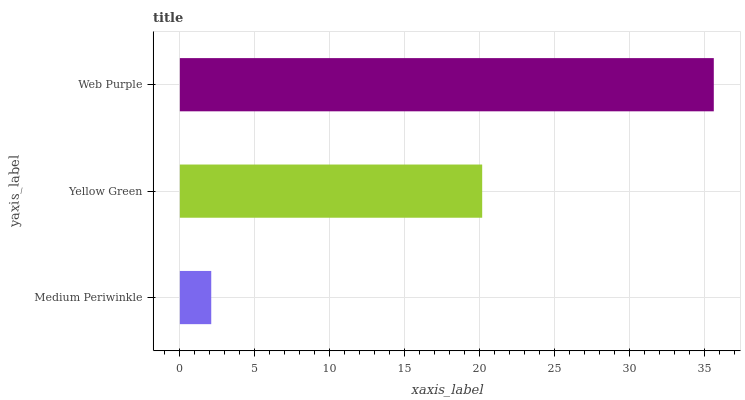Is Medium Periwinkle the minimum?
Answer yes or no. Yes. Is Web Purple the maximum?
Answer yes or no. Yes. Is Yellow Green the minimum?
Answer yes or no. No. Is Yellow Green the maximum?
Answer yes or no. No. Is Yellow Green greater than Medium Periwinkle?
Answer yes or no. Yes. Is Medium Periwinkle less than Yellow Green?
Answer yes or no. Yes. Is Medium Periwinkle greater than Yellow Green?
Answer yes or no. No. Is Yellow Green less than Medium Periwinkle?
Answer yes or no. No. Is Yellow Green the high median?
Answer yes or no. Yes. Is Yellow Green the low median?
Answer yes or no. Yes. Is Medium Periwinkle the high median?
Answer yes or no. No. Is Web Purple the low median?
Answer yes or no. No. 